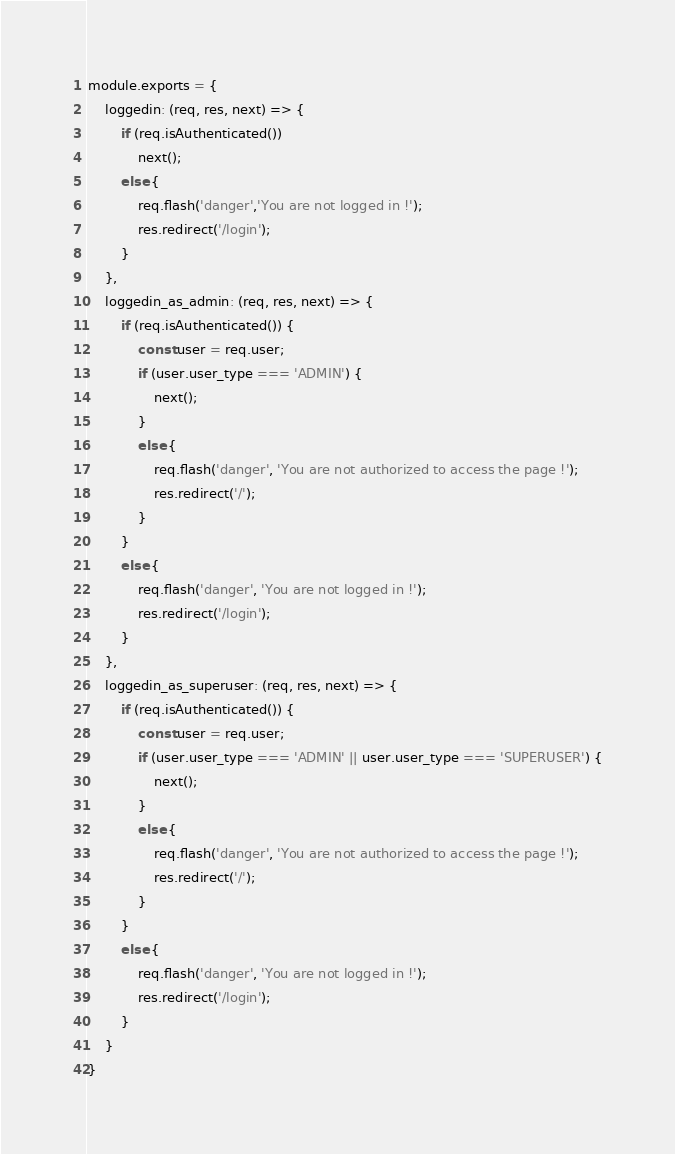Convert code to text. <code><loc_0><loc_0><loc_500><loc_500><_JavaScript_>module.exports = {
    loggedin: (req, res, next) => {
        if (req.isAuthenticated())
            next();
        else {
            req.flash('danger','You are not logged in !');
            res.redirect('/login');
        }            
    },
    loggedin_as_admin: (req, res, next) => {
        if (req.isAuthenticated()) {
            const user = req.user;
            if (user.user_type === 'ADMIN') {
                next();
            }
            else {
                req.flash('danger', 'You are not authorized to access the page !');
                res.redirect('/');
            }
        }
        else {
            req.flash('danger', 'You are not logged in !');
            res.redirect('/login');
        }
    },
    loggedin_as_superuser: (req, res, next) => {
        if (req.isAuthenticated()) {
            const user = req.user;
            if (user.user_type === 'ADMIN' || user.user_type === 'SUPERUSER') {
                next();
            }
            else {
                req.flash('danger', 'You are not authorized to access the page !');
                res.redirect('/');
            }
        }
        else {
            req.flash('danger', 'You are not logged in !');
            res.redirect('/login');
        }
    }
}</code> 